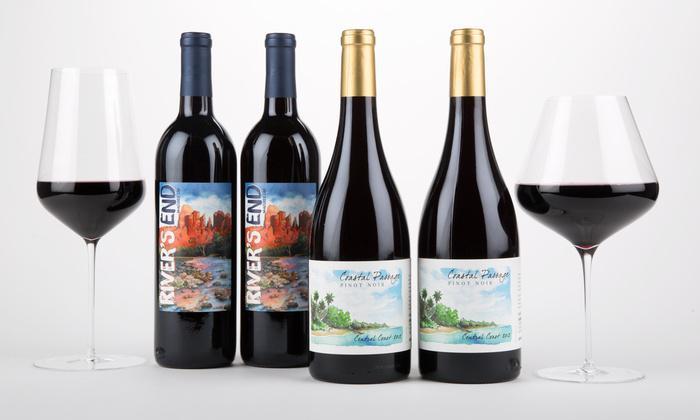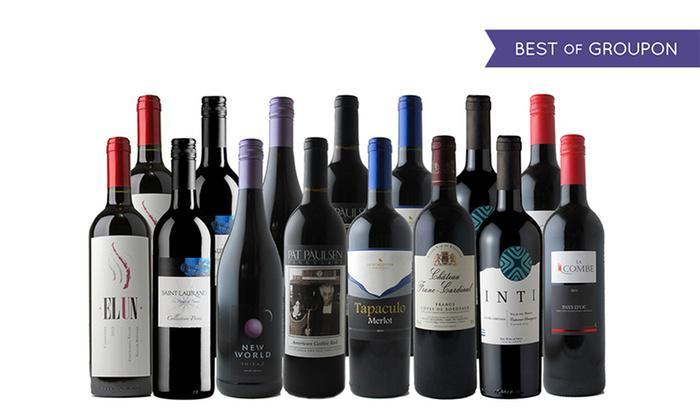The first image is the image on the left, the second image is the image on the right. Given the left and right images, does the statement "The left image includes two wine glasses." hold true? Answer yes or no. Yes. The first image is the image on the left, the second image is the image on the right. Assess this claim about the two images: "A single bottle of wine stands in the image on the left.". Correct or not? Answer yes or no. No. 